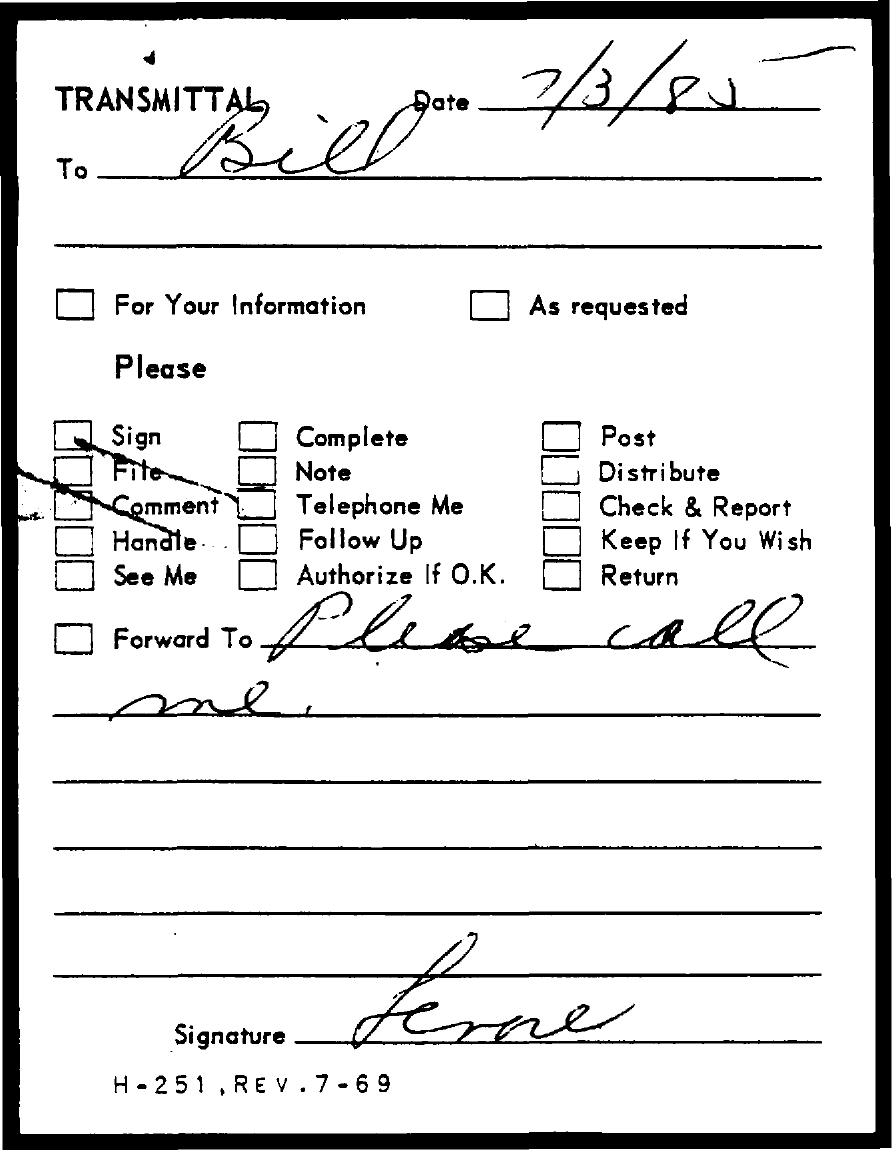To whom, the transmittal is addressed?
Your answer should be very brief. Bill. 